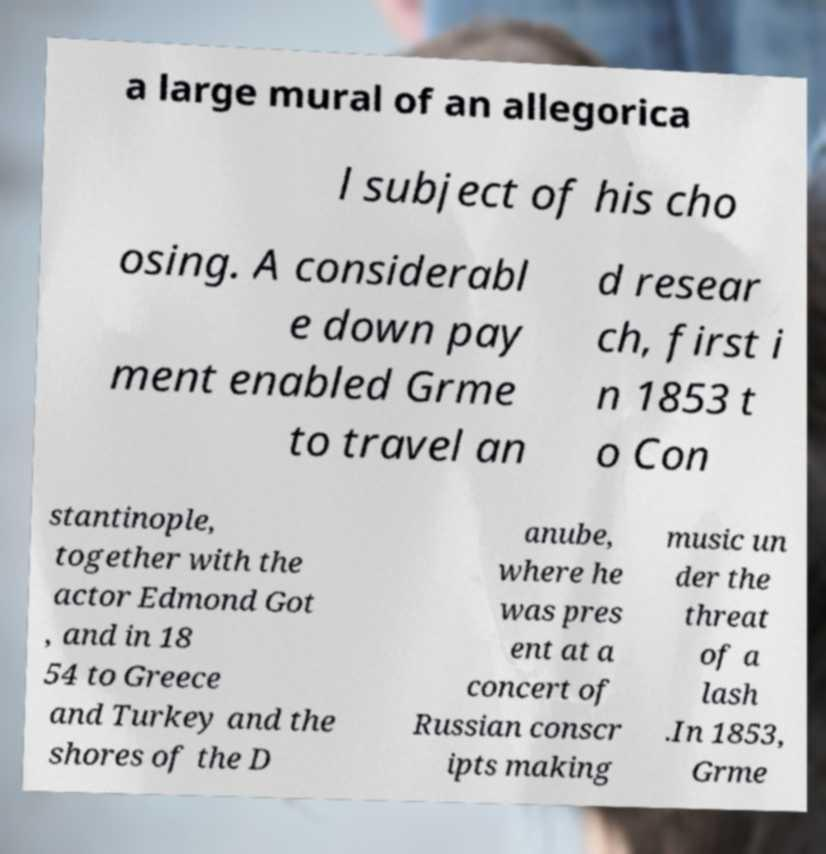For documentation purposes, I need the text within this image transcribed. Could you provide that? a large mural of an allegorica l subject of his cho osing. A considerabl e down pay ment enabled Grme to travel an d resear ch, first i n 1853 t o Con stantinople, together with the actor Edmond Got , and in 18 54 to Greece and Turkey and the shores of the D anube, where he was pres ent at a concert of Russian conscr ipts making music un der the threat of a lash .In 1853, Grme 